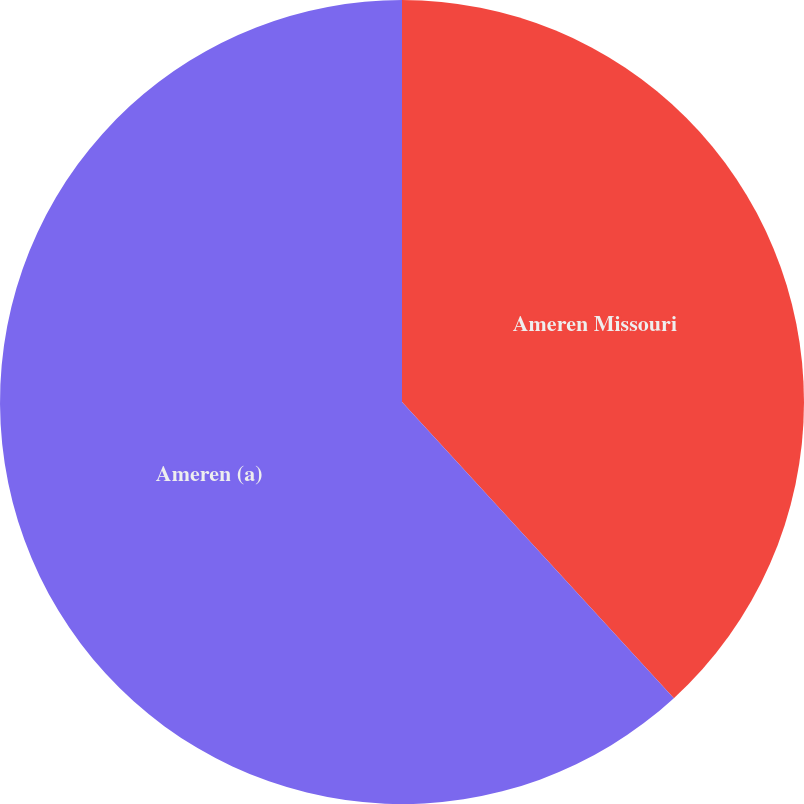Convert chart. <chart><loc_0><loc_0><loc_500><loc_500><pie_chart><fcel>Ameren Missouri<fcel>Ameren (a)<nl><fcel>38.18%<fcel>61.82%<nl></chart> 